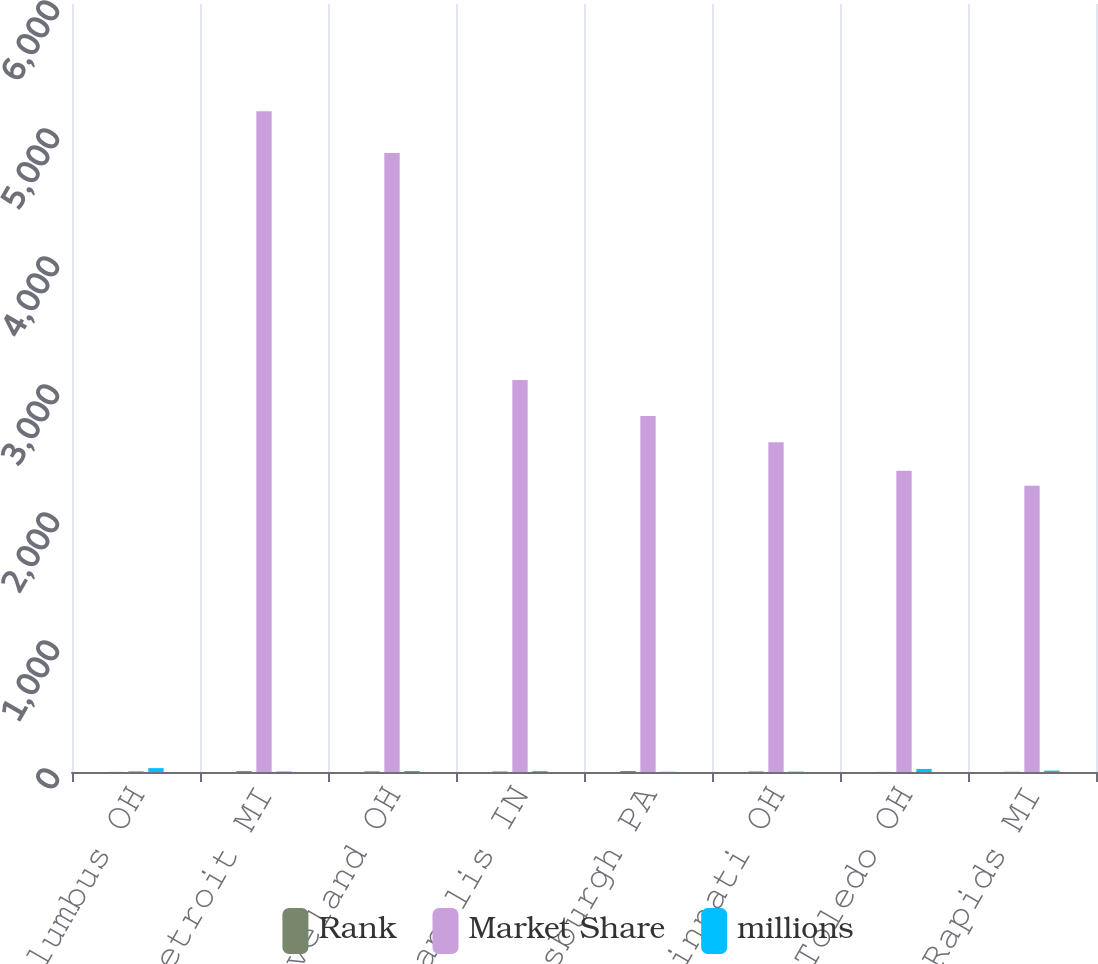<chart> <loc_0><loc_0><loc_500><loc_500><stacked_bar_chart><ecel><fcel>Columbus OH<fcel>Detroit MI<fcel>Cleveland OH<fcel>Indianapolis IN<fcel>Pittsburgh PA<fcel>Cincinnati OH<fcel>Toledo OH<fcel>Grand Rapids MI<nl><fcel>Rank<fcel>1<fcel>7<fcel>5<fcel>4<fcel>8<fcel>4<fcel>1<fcel>2<nl><fcel>Market Share<fcel>8<fcel>5163<fcel>4836<fcel>3062<fcel>2782<fcel>2577<fcel>2354<fcel>2237<nl><fcel>millions<fcel>30<fcel>4<fcel>8<fcel>7<fcel>2<fcel>3<fcel>24<fcel>11<nl></chart> 